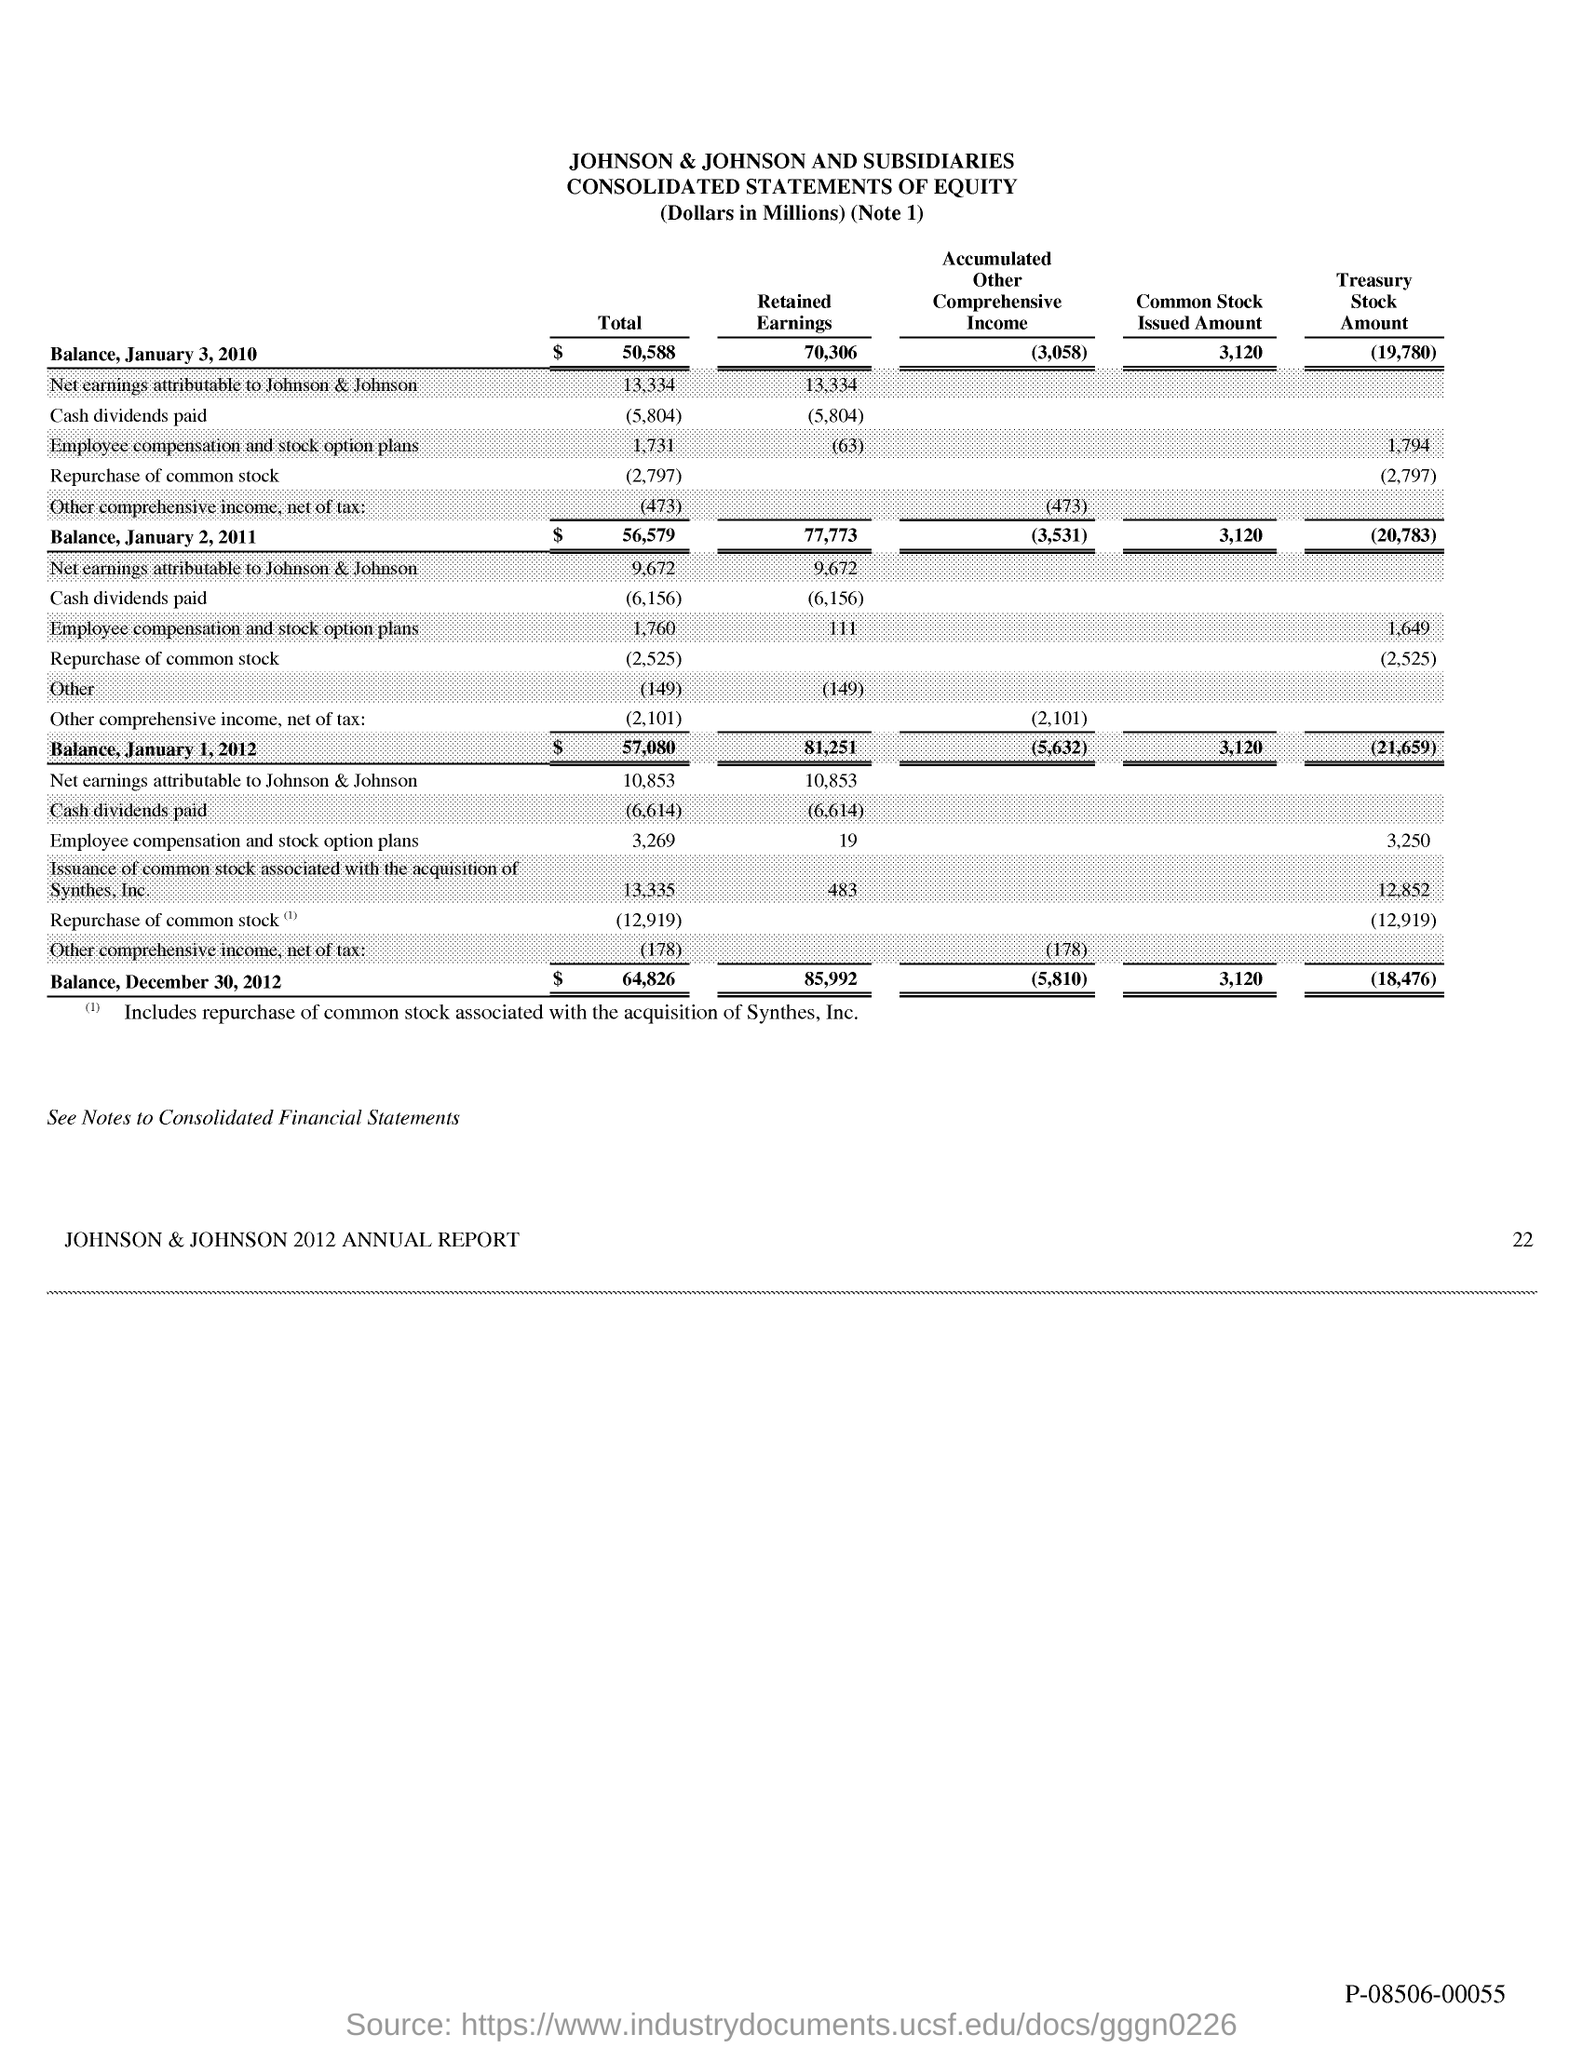What is the total balance as on january 3, 2010?
Your answer should be very brief. $ 50,588. What is the total balance as on january 2, 2011?
Provide a short and direct response. $56579. What is the total balance as on january 1, 2012?
Your response must be concise. 57,080. What is the total balance as on december 30, 2012?
Give a very brief answer. 64,826. What is the retained earnings as on january 3, 2010?
Keep it short and to the point. 70306. What is the common stock issued amount as on january 3,, 2010?
Your answer should be compact. 3120. 